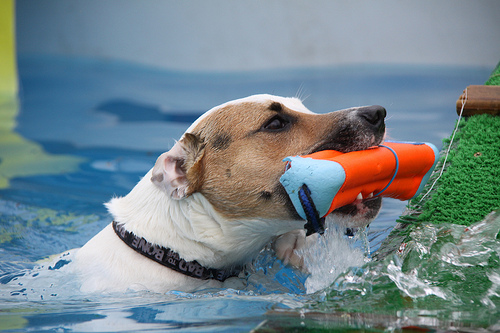<image>
Is the dog next to the water? No. The dog is not positioned next to the water. They are located in different areas of the scene. 